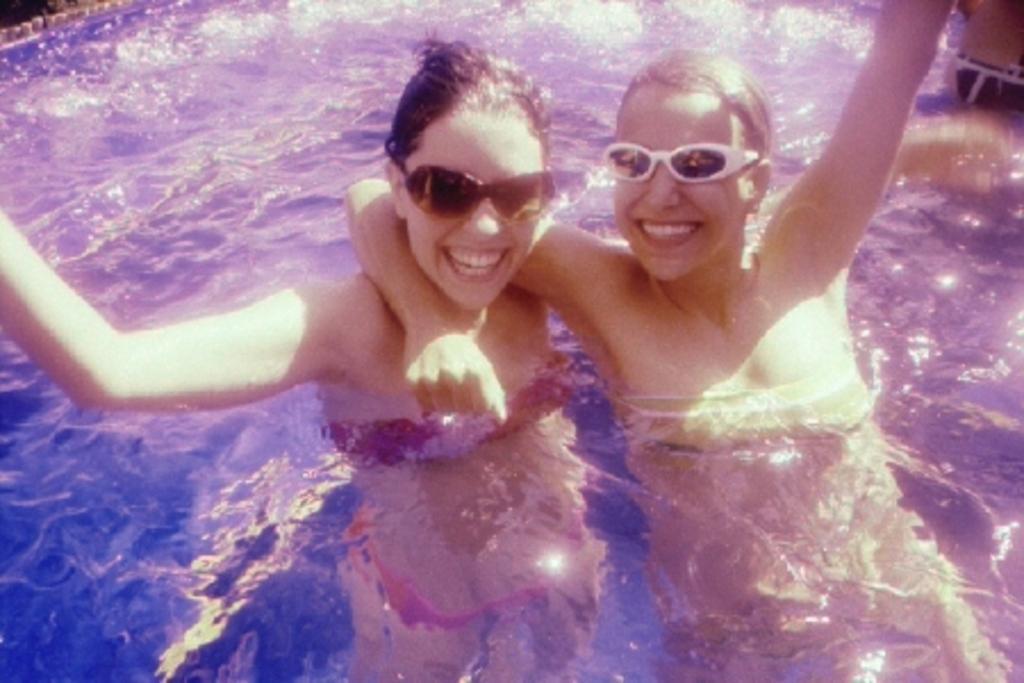Could you give a brief overview of what you see in this image? In this image, there is water, in that water there are two persons standing. 